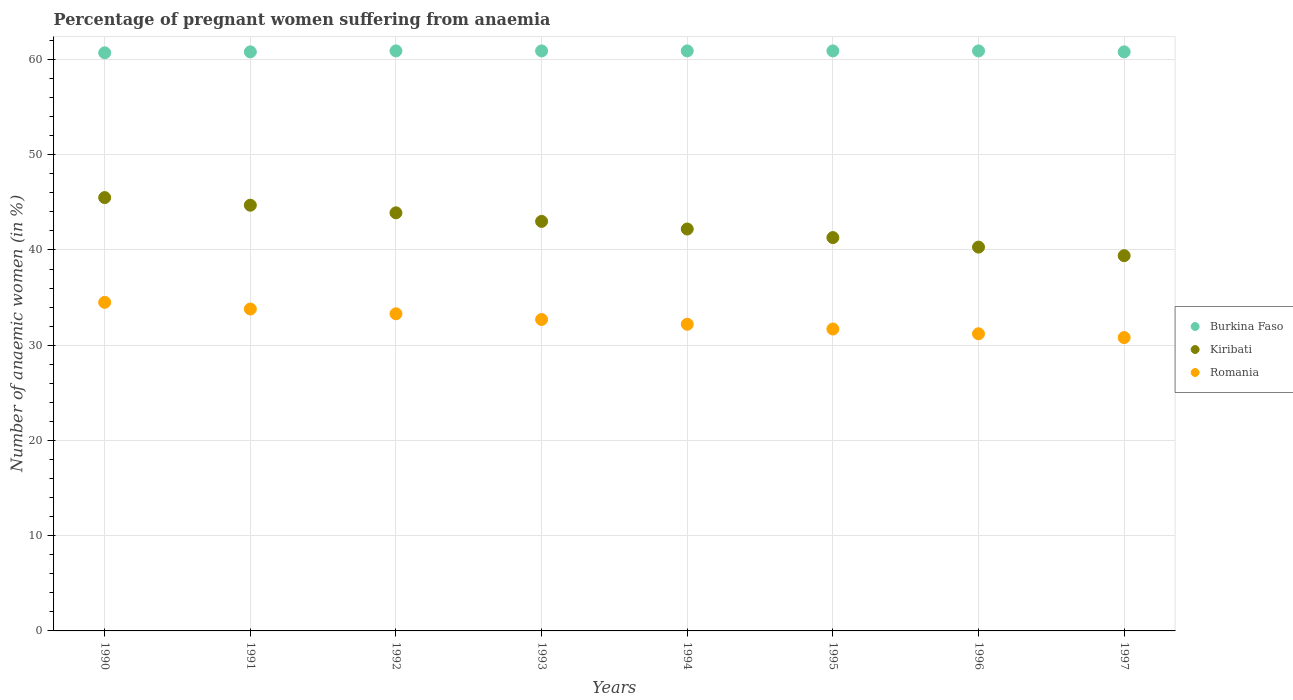How many different coloured dotlines are there?
Offer a terse response. 3. Is the number of dotlines equal to the number of legend labels?
Your answer should be compact. Yes. What is the number of anaemic women in Romania in 1990?
Offer a terse response. 34.5. Across all years, what is the maximum number of anaemic women in Burkina Faso?
Keep it short and to the point. 60.9. Across all years, what is the minimum number of anaemic women in Romania?
Give a very brief answer. 30.8. What is the total number of anaemic women in Kiribati in the graph?
Ensure brevity in your answer.  340.3. What is the difference between the number of anaemic women in Kiribati in 1993 and that in 1994?
Offer a very short reply. 0.8. What is the difference between the number of anaemic women in Burkina Faso in 1994 and the number of anaemic women in Romania in 1997?
Provide a short and direct response. 30.1. What is the average number of anaemic women in Romania per year?
Make the answer very short. 32.53. In the year 1995, what is the difference between the number of anaemic women in Kiribati and number of anaemic women in Burkina Faso?
Give a very brief answer. -19.6. What is the ratio of the number of anaemic women in Romania in 1990 to that in 1996?
Your response must be concise. 1.11. Is the difference between the number of anaemic women in Kiribati in 1991 and 1997 greater than the difference between the number of anaemic women in Burkina Faso in 1991 and 1997?
Provide a short and direct response. Yes. What is the difference between the highest and the second highest number of anaemic women in Burkina Faso?
Your answer should be very brief. 0. What is the difference between the highest and the lowest number of anaemic women in Kiribati?
Provide a succinct answer. 6.1. Is the sum of the number of anaemic women in Kiribati in 1996 and 1997 greater than the maximum number of anaemic women in Burkina Faso across all years?
Provide a succinct answer. Yes. Is it the case that in every year, the sum of the number of anaemic women in Kiribati and number of anaemic women in Burkina Faso  is greater than the number of anaemic women in Romania?
Keep it short and to the point. Yes. Does the number of anaemic women in Kiribati monotonically increase over the years?
Your answer should be compact. No. How many dotlines are there?
Your answer should be compact. 3. How many years are there in the graph?
Keep it short and to the point. 8. What is the difference between two consecutive major ticks on the Y-axis?
Provide a short and direct response. 10. Are the values on the major ticks of Y-axis written in scientific E-notation?
Keep it short and to the point. No. Does the graph contain any zero values?
Make the answer very short. No. How many legend labels are there?
Provide a short and direct response. 3. What is the title of the graph?
Offer a very short reply. Percentage of pregnant women suffering from anaemia. Does "Benin" appear as one of the legend labels in the graph?
Your answer should be compact. No. What is the label or title of the X-axis?
Provide a succinct answer. Years. What is the label or title of the Y-axis?
Your response must be concise. Number of anaemic women (in %). What is the Number of anaemic women (in %) of Burkina Faso in 1990?
Ensure brevity in your answer.  60.7. What is the Number of anaemic women (in %) of Kiribati in 1990?
Offer a very short reply. 45.5. What is the Number of anaemic women (in %) in Romania in 1990?
Your answer should be compact. 34.5. What is the Number of anaemic women (in %) in Burkina Faso in 1991?
Keep it short and to the point. 60.8. What is the Number of anaemic women (in %) of Kiribati in 1991?
Provide a succinct answer. 44.7. What is the Number of anaemic women (in %) in Romania in 1991?
Your answer should be compact. 33.8. What is the Number of anaemic women (in %) in Burkina Faso in 1992?
Keep it short and to the point. 60.9. What is the Number of anaemic women (in %) of Kiribati in 1992?
Make the answer very short. 43.9. What is the Number of anaemic women (in %) in Romania in 1992?
Offer a very short reply. 33.3. What is the Number of anaemic women (in %) in Burkina Faso in 1993?
Your answer should be very brief. 60.9. What is the Number of anaemic women (in %) of Kiribati in 1993?
Give a very brief answer. 43. What is the Number of anaemic women (in %) of Romania in 1993?
Your answer should be compact. 32.7. What is the Number of anaemic women (in %) of Burkina Faso in 1994?
Provide a short and direct response. 60.9. What is the Number of anaemic women (in %) in Kiribati in 1994?
Your answer should be very brief. 42.2. What is the Number of anaemic women (in %) in Romania in 1994?
Provide a succinct answer. 32.2. What is the Number of anaemic women (in %) of Burkina Faso in 1995?
Give a very brief answer. 60.9. What is the Number of anaemic women (in %) of Kiribati in 1995?
Provide a short and direct response. 41.3. What is the Number of anaemic women (in %) of Romania in 1995?
Keep it short and to the point. 31.7. What is the Number of anaemic women (in %) in Burkina Faso in 1996?
Give a very brief answer. 60.9. What is the Number of anaemic women (in %) of Kiribati in 1996?
Your response must be concise. 40.3. What is the Number of anaemic women (in %) of Romania in 1996?
Ensure brevity in your answer.  31.2. What is the Number of anaemic women (in %) in Burkina Faso in 1997?
Give a very brief answer. 60.8. What is the Number of anaemic women (in %) of Kiribati in 1997?
Offer a terse response. 39.4. What is the Number of anaemic women (in %) in Romania in 1997?
Keep it short and to the point. 30.8. Across all years, what is the maximum Number of anaemic women (in %) in Burkina Faso?
Your response must be concise. 60.9. Across all years, what is the maximum Number of anaemic women (in %) in Kiribati?
Provide a succinct answer. 45.5. Across all years, what is the maximum Number of anaemic women (in %) in Romania?
Offer a very short reply. 34.5. Across all years, what is the minimum Number of anaemic women (in %) of Burkina Faso?
Your response must be concise. 60.7. Across all years, what is the minimum Number of anaemic women (in %) in Kiribati?
Offer a terse response. 39.4. Across all years, what is the minimum Number of anaemic women (in %) in Romania?
Provide a succinct answer. 30.8. What is the total Number of anaemic women (in %) in Burkina Faso in the graph?
Provide a short and direct response. 486.8. What is the total Number of anaemic women (in %) in Kiribati in the graph?
Your response must be concise. 340.3. What is the total Number of anaemic women (in %) in Romania in the graph?
Ensure brevity in your answer.  260.2. What is the difference between the Number of anaemic women (in %) in Kiribati in 1990 and that in 1991?
Keep it short and to the point. 0.8. What is the difference between the Number of anaemic women (in %) of Romania in 1990 and that in 1991?
Your answer should be very brief. 0.7. What is the difference between the Number of anaemic women (in %) in Burkina Faso in 1990 and that in 1992?
Make the answer very short. -0.2. What is the difference between the Number of anaemic women (in %) of Romania in 1990 and that in 1992?
Keep it short and to the point. 1.2. What is the difference between the Number of anaemic women (in %) of Romania in 1990 and that in 1993?
Offer a very short reply. 1.8. What is the difference between the Number of anaemic women (in %) of Kiribati in 1990 and that in 1994?
Provide a short and direct response. 3.3. What is the difference between the Number of anaemic women (in %) of Romania in 1990 and that in 1994?
Make the answer very short. 2.3. What is the difference between the Number of anaemic women (in %) of Burkina Faso in 1990 and that in 1995?
Offer a terse response. -0.2. What is the difference between the Number of anaemic women (in %) of Romania in 1990 and that in 1996?
Provide a succinct answer. 3.3. What is the difference between the Number of anaemic women (in %) in Kiribati in 1990 and that in 1997?
Provide a succinct answer. 6.1. What is the difference between the Number of anaemic women (in %) in Romania in 1990 and that in 1997?
Make the answer very short. 3.7. What is the difference between the Number of anaemic women (in %) of Kiribati in 1991 and that in 1992?
Make the answer very short. 0.8. What is the difference between the Number of anaemic women (in %) of Burkina Faso in 1991 and that in 1993?
Offer a terse response. -0.1. What is the difference between the Number of anaemic women (in %) in Kiribati in 1991 and that in 1993?
Provide a short and direct response. 1.7. What is the difference between the Number of anaemic women (in %) of Romania in 1991 and that in 1993?
Ensure brevity in your answer.  1.1. What is the difference between the Number of anaemic women (in %) of Burkina Faso in 1991 and that in 1994?
Give a very brief answer. -0.1. What is the difference between the Number of anaemic women (in %) in Romania in 1991 and that in 1995?
Provide a short and direct response. 2.1. What is the difference between the Number of anaemic women (in %) in Burkina Faso in 1991 and that in 1996?
Keep it short and to the point. -0.1. What is the difference between the Number of anaemic women (in %) of Kiribati in 1991 and that in 1996?
Your response must be concise. 4.4. What is the difference between the Number of anaemic women (in %) of Romania in 1991 and that in 1997?
Offer a very short reply. 3. What is the difference between the Number of anaemic women (in %) of Romania in 1992 and that in 1993?
Your answer should be very brief. 0.6. What is the difference between the Number of anaemic women (in %) in Burkina Faso in 1992 and that in 1994?
Offer a terse response. 0. What is the difference between the Number of anaemic women (in %) of Romania in 1992 and that in 1994?
Ensure brevity in your answer.  1.1. What is the difference between the Number of anaemic women (in %) in Burkina Faso in 1992 and that in 1995?
Ensure brevity in your answer.  0. What is the difference between the Number of anaemic women (in %) of Romania in 1992 and that in 1995?
Ensure brevity in your answer.  1.6. What is the difference between the Number of anaemic women (in %) of Kiribati in 1992 and that in 1996?
Offer a very short reply. 3.6. What is the difference between the Number of anaemic women (in %) in Burkina Faso in 1992 and that in 1997?
Provide a succinct answer. 0.1. What is the difference between the Number of anaemic women (in %) of Burkina Faso in 1993 and that in 1995?
Give a very brief answer. 0. What is the difference between the Number of anaemic women (in %) of Burkina Faso in 1993 and that in 1996?
Ensure brevity in your answer.  0. What is the difference between the Number of anaemic women (in %) of Kiribati in 1993 and that in 1996?
Offer a terse response. 2.7. What is the difference between the Number of anaemic women (in %) of Romania in 1993 and that in 1996?
Offer a terse response. 1.5. What is the difference between the Number of anaemic women (in %) in Burkina Faso in 1993 and that in 1997?
Keep it short and to the point. 0.1. What is the difference between the Number of anaemic women (in %) of Romania in 1993 and that in 1997?
Offer a very short reply. 1.9. What is the difference between the Number of anaemic women (in %) in Kiribati in 1994 and that in 1995?
Provide a short and direct response. 0.9. What is the difference between the Number of anaemic women (in %) in Burkina Faso in 1994 and that in 1996?
Provide a short and direct response. 0. What is the difference between the Number of anaemic women (in %) in Romania in 1994 and that in 1996?
Offer a very short reply. 1. What is the difference between the Number of anaemic women (in %) in Burkina Faso in 1994 and that in 1997?
Provide a short and direct response. 0.1. What is the difference between the Number of anaemic women (in %) of Kiribati in 1995 and that in 1996?
Provide a short and direct response. 1. What is the difference between the Number of anaemic women (in %) in Romania in 1995 and that in 1996?
Offer a terse response. 0.5. What is the difference between the Number of anaemic women (in %) in Burkina Faso in 1995 and that in 1997?
Give a very brief answer. 0.1. What is the difference between the Number of anaemic women (in %) of Kiribati in 1995 and that in 1997?
Your answer should be compact. 1.9. What is the difference between the Number of anaemic women (in %) in Romania in 1995 and that in 1997?
Offer a very short reply. 0.9. What is the difference between the Number of anaemic women (in %) in Burkina Faso in 1996 and that in 1997?
Give a very brief answer. 0.1. What is the difference between the Number of anaemic women (in %) of Romania in 1996 and that in 1997?
Offer a very short reply. 0.4. What is the difference between the Number of anaemic women (in %) of Burkina Faso in 1990 and the Number of anaemic women (in %) of Romania in 1991?
Make the answer very short. 26.9. What is the difference between the Number of anaemic women (in %) in Kiribati in 1990 and the Number of anaemic women (in %) in Romania in 1991?
Offer a terse response. 11.7. What is the difference between the Number of anaemic women (in %) of Burkina Faso in 1990 and the Number of anaemic women (in %) of Kiribati in 1992?
Provide a short and direct response. 16.8. What is the difference between the Number of anaemic women (in %) of Burkina Faso in 1990 and the Number of anaemic women (in %) of Romania in 1992?
Your response must be concise. 27.4. What is the difference between the Number of anaemic women (in %) of Burkina Faso in 1990 and the Number of anaemic women (in %) of Romania in 1993?
Offer a terse response. 28. What is the difference between the Number of anaemic women (in %) in Burkina Faso in 1990 and the Number of anaemic women (in %) in Kiribati in 1995?
Provide a short and direct response. 19.4. What is the difference between the Number of anaemic women (in %) in Burkina Faso in 1990 and the Number of anaemic women (in %) in Kiribati in 1996?
Provide a short and direct response. 20.4. What is the difference between the Number of anaemic women (in %) in Burkina Faso in 1990 and the Number of anaemic women (in %) in Romania in 1996?
Give a very brief answer. 29.5. What is the difference between the Number of anaemic women (in %) in Burkina Faso in 1990 and the Number of anaemic women (in %) in Kiribati in 1997?
Your answer should be very brief. 21.3. What is the difference between the Number of anaemic women (in %) of Burkina Faso in 1990 and the Number of anaemic women (in %) of Romania in 1997?
Your response must be concise. 29.9. What is the difference between the Number of anaemic women (in %) of Kiribati in 1990 and the Number of anaemic women (in %) of Romania in 1997?
Your response must be concise. 14.7. What is the difference between the Number of anaemic women (in %) of Burkina Faso in 1991 and the Number of anaemic women (in %) of Kiribati in 1992?
Give a very brief answer. 16.9. What is the difference between the Number of anaemic women (in %) in Burkina Faso in 1991 and the Number of anaemic women (in %) in Romania in 1992?
Offer a terse response. 27.5. What is the difference between the Number of anaemic women (in %) in Burkina Faso in 1991 and the Number of anaemic women (in %) in Kiribati in 1993?
Your answer should be compact. 17.8. What is the difference between the Number of anaemic women (in %) of Burkina Faso in 1991 and the Number of anaemic women (in %) of Romania in 1993?
Give a very brief answer. 28.1. What is the difference between the Number of anaemic women (in %) of Kiribati in 1991 and the Number of anaemic women (in %) of Romania in 1993?
Provide a succinct answer. 12. What is the difference between the Number of anaemic women (in %) in Burkina Faso in 1991 and the Number of anaemic women (in %) in Kiribati in 1994?
Provide a short and direct response. 18.6. What is the difference between the Number of anaemic women (in %) in Burkina Faso in 1991 and the Number of anaemic women (in %) in Romania in 1994?
Your answer should be compact. 28.6. What is the difference between the Number of anaemic women (in %) in Kiribati in 1991 and the Number of anaemic women (in %) in Romania in 1994?
Make the answer very short. 12.5. What is the difference between the Number of anaemic women (in %) of Burkina Faso in 1991 and the Number of anaemic women (in %) of Romania in 1995?
Your answer should be very brief. 29.1. What is the difference between the Number of anaemic women (in %) in Kiribati in 1991 and the Number of anaemic women (in %) in Romania in 1995?
Give a very brief answer. 13. What is the difference between the Number of anaemic women (in %) in Burkina Faso in 1991 and the Number of anaemic women (in %) in Kiribati in 1996?
Offer a very short reply. 20.5. What is the difference between the Number of anaemic women (in %) of Burkina Faso in 1991 and the Number of anaemic women (in %) of Romania in 1996?
Provide a succinct answer. 29.6. What is the difference between the Number of anaemic women (in %) of Burkina Faso in 1991 and the Number of anaemic women (in %) of Kiribati in 1997?
Provide a short and direct response. 21.4. What is the difference between the Number of anaemic women (in %) of Burkina Faso in 1992 and the Number of anaemic women (in %) of Kiribati in 1993?
Give a very brief answer. 17.9. What is the difference between the Number of anaemic women (in %) in Burkina Faso in 1992 and the Number of anaemic women (in %) in Romania in 1993?
Give a very brief answer. 28.2. What is the difference between the Number of anaemic women (in %) in Kiribati in 1992 and the Number of anaemic women (in %) in Romania in 1993?
Your response must be concise. 11.2. What is the difference between the Number of anaemic women (in %) in Burkina Faso in 1992 and the Number of anaemic women (in %) in Kiribati in 1994?
Your answer should be very brief. 18.7. What is the difference between the Number of anaemic women (in %) of Burkina Faso in 1992 and the Number of anaemic women (in %) of Romania in 1994?
Provide a short and direct response. 28.7. What is the difference between the Number of anaemic women (in %) of Kiribati in 1992 and the Number of anaemic women (in %) of Romania in 1994?
Provide a short and direct response. 11.7. What is the difference between the Number of anaemic women (in %) of Burkina Faso in 1992 and the Number of anaemic women (in %) of Kiribati in 1995?
Your response must be concise. 19.6. What is the difference between the Number of anaemic women (in %) of Burkina Faso in 1992 and the Number of anaemic women (in %) of Romania in 1995?
Give a very brief answer. 29.2. What is the difference between the Number of anaemic women (in %) in Burkina Faso in 1992 and the Number of anaemic women (in %) in Kiribati in 1996?
Offer a terse response. 20.6. What is the difference between the Number of anaemic women (in %) in Burkina Faso in 1992 and the Number of anaemic women (in %) in Romania in 1996?
Keep it short and to the point. 29.7. What is the difference between the Number of anaemic women (in %) of Burkina Faso in 1992 and the Number of anaemic women (in %) of Kiribati in 1997?
Keep it short and to the point. 21.5. What is the difference between the Number of anaemic women (in %) in Burkina Faso in 1992 and the Number of anaemic women (in %) in Romania in 1997?
Your answer should be compact. 30.1. What is the difference between the Number of anaemic women (in %) of Kiribati in 1992 and the Number of anaemic women (in %) of Romania in 1997?
Offer a very short reply. 13.1. What is the difference between the Number of anaemic women (in %) of Burkina Faso in 1993 and the Number of anaemic women (in %) of Romania in 1994?
Ensure brevity in your answer.  28.7. What is the difference between the Number of anaemic women (in %) of Burkina Faso in 1993 and the Number of anaemic women (in %) of Kiribati in 1995?
Keep it short and to the point. 19.6. What is the difference between the Number of anaemic women (in %) in Burkina Faso in 1993 and the Number of anaemic women (in %) in Romania in 1995?
Provide a succinct answer. 29.2. What is the difference between the Number of anaemic women (in %) in Burkina Faso in 1993 and the Number of anaemic women (in %) in Kiribati in 1996?
Your answer should be compact. 20.6. What is the difference between the Number of anaemic women (in %) in Burkina Faso in 1993 and the Number of anaemic women (in %) in Romania in 1996?
Offer a terse response. 29.7. What is the difference between the Number of anaemic women (in %) of Burkina Faso in 1993 and the Number of anaemic women (in %) of Kiribati in 1997?
Provide a short and direct response. 21.5. What is the difference between the Number of anaemic women (in %) of Burkina Faso in 1993 and the Number of anaemic women (in %) of Romania in 1997?
Your answer should be very brief. 30.1. What is the difference between the Number of anaemic women (in %) in Kiribati in 1993 and the Number of anaemic women (in %) in Romania in 1997?
Make the answer very short. 12.2. What is the difference between the Number of anaemic women (in %) in Burkina Faso in 1994 and the Number of anaemic women (in %) in Kiribati in 1995?
Provide a succinct answer. 19.6. What is the difference between the Number of anaemic women (in %) in Burkina Faso in 1994 and the Number of anaemic women (in %) in Romania in 1995?
Provide a short and direct response. 29.2. What is the difference between the Number of anaemic women (in %) of Burkina Faso in 1994 and the Number of anaemic women (in %) of Kiribati in 1996?
Ensure brevity in your answer.  20.6. What is the difference between the Number of anaemic women (in %) in Burkina Faso in 1994 and the Number of anaemic women (in %) in Romania in 1996?
Offer a very short reply. 29.7. What is the difference between the Number of anaemic women (in %) of Kiribati in 1994 and the Number of anaemic women (in %) of Romania in 1996?
Make the answer very short. 11. What is the difference between the Number of anaemic women (in %) of Burkina Faso in 1994 and the Number of anaemic women (in %) of Kiribati in 1997?
Keep it short and to the point. 21.5. What is the difference between the Number of anaemic women (in %) of Burkina Faso in 1994 and the Number of anaemic women (in %) of Romania in 1997?
Provide a succinct answer. 30.1. What is the difference between the Number of anaemic women (in %) in Burkina Faso in 1995 and the Number of anaemic women (in %) in Kiribati in 1996?
Give a very brief answer. 20.6. What is the difference between the Number of anaemic women (in %) in Burkina Faso in 1995 and the Number of anaemic women (in %) in Romania in 1996?
Make the answer very short. 29.7. What is the difference between the Number of anaemic women (in %) in Burkina Faso in 1995 and the Number of anaemic women (in %) in Romania in 1997?
Your answer should be very brief. 30.1. What is the difference between the Number of anaemic women (in %) in Kiribati in 1995 and the Number of anaemic women (in %) in Romania in 1997?
Give a very brief answer. 10.5. What is the difference between the Number of anaemic women (in %) in Burkina Faso in 1996 and the Number of anaemic women (in %) in Kiribati in 1997?
Your answer should be compact. 21.5. What is the difference between the Number of anaemic women (in %) in Burkina Faso in 1996 and the Number of anaemic women (in %) in Romania in 1997?
Provide a short and direct response. 30.1. What is the average Number of anaemic women (in %) of Burkina Faso per year?
Keep it short and to the point. 60.85. What is the average Number of anaemic women (in %) in Kiribati per year?
Give a very brief answer. 42.54. What is the average Number of anaemic women (in %) in Romania per year?
Your response must be concise. 32.52. In the year 1990, what is the difference between the Number of anaemic women (in %) of Burkina Faso and Number of anaemic women (in %) of Romania?
Offer a very short reply. 26.2. In the year 1991, what is the difference between the Number of anaemic women (in %) in Burkina Faso and Number of anaemic women (in %) in Kiribati?
Your response must be concise. 16.1. In the year 1991, what is the difference between the Number of anaemic women (in %) in Burkina Faso and Number of anaemic women (in %) in Romania?
Provide a short and direct response. 27. In the year 1991, what is the difference between the Number of anaemic women (in %) in Kiribati and Number of anaemic women (in %) in Romania?
Your answer should be very brief. 10.9. In the year 1992, what is the difference between the Number of anaemic women (in %) of Burkina Faso and Number of anaemic women (in %) of Romania?
Offer a very short reply. 27.6. In the year 1992, what is the difference between the Number of anaemic women (in %) in Kiribati and Number of anaemic women (in %) in Romania?
Offer a terse response. 10.6. In the year 1993, what is the difference between the Number of anaemic women (in %) of Burkina Faso and Number of anaemic women (in %) of Romania?
Your answer should be very brief. 28.2. In the year 1993, what is the difference between the Number of anaemic women (in %) of Kiribati and Number of anaemic women (in %) of Romania?
Give a very brief answer. 10.3. In the year 1994, what is the difference between the Number of anaemic women (in %) of Burkina Faso and Number of anaemic women (in %) of Kiribati?
Provide a short and direct response. 18.7. In the year 1994, what is the difference between the Number of anaemic women (in %) in Burkina Faso and Number of anaemic women (in %) in Romania?
Ensure brevity in your answer.  28.7. In the year 1995, what is the difference between the Number of anaemic women (in %) of Burkina Faso and Number of anaemic women (in %) of Kiribati?
Give a very brief answer. 19.6. In the year 1995, what is the difference between the Number of anaemic women (in %) of Burkina Faso and Number of anaemic women (in %) of Romania?
Offer a terse response. 29.2. In the year 1995, what is the difference between the Number of anaemic women (in %) of Kiribati and Number of anaemic women (in %) of Romania?
Your response must be concise. 9.6. In the year 1996, what is the difference between the Number of anaemic women (in %) of Burkina Faso and Number of anaemic women (in %) of Kiribati?
Ensure brevity in your answer.  20.6. In the year 1996, what is the difference between the Number of anaemic women (in %) in Burkina Faso and Number of anaemic women (in %) in Romania?
Provide a short and direct response. 29.7. In the year 1997, what is the difference between the Number of anaemic women (in %) of Burkina Faso and Number of anaemic women (in %) of Kiribati?
Offer a terse response. 21.4. In the year 1997, what is the difference between the Number of anaemic women (in %) of Burkina Faso and Number of anaemic women (in %) of Romania?
Offer a terse response. 30. In the year 1997, what is the difference between the Number of anaemic women (in %) in Kiribati and Number of anaemic women (in %) in Romania?
Offer a terse response. 8.6. What is the ratio of the Number of anaemic women (in %) of Burkina Faso in 1990 to that in 1991?
Ensure brevity in your answer.  1. What is the ratio of the Number of anaemic women (in %) of Kiribati in 1990 to that in 1991?
Provide a succinct answer. 1.02. What is the ratio of the Number of anaemic women (in %) in Romania in 1990 to that in 1991?
Make the answer very short. 1.02. What is the ratio of the Number of anaemic women (in %) in Burkina Faso in 1990 to that in 1992?
Your answer should be compact. 1. What is the ratio of the Number of anaemic women (in %) in Kiribati in 1990 to that in 1992?
Provide a short and direct response. 1.04. What is the ratio of the Number of anaemic women (in %) of Romania in 1990 to that in 1992?
Give a very brief answer. 1.04. What is the ratio of the Number of anaemic women (in %) in Kiribati in 1990 to that in 1993?
Offer a terse response. 1.06. What is the ratio of the Number of anaemic women (in %) in Romania in 1990 to that in 1993?
Keep it short and to the point. 1.05. What is the ratio of the Number of anaemic women (in %) of Kiribati in 1990 to that in 1994?
Your answer should be compact. 1.08. What is the ratio of the Number of anaemic women (in %) of Romania in 1990 to that in 1994?
Make the answer very short. 1.07. What is the ratio of the Number of anaemic women (in %) in Kiribati in 1990 to that in 1995?
Your response must be concise. 1.1. What is the ratio of the Number of anaemic women (in %) in Romania in 1990 to that in 1995?
Give a very brief answer. 1.09. What is the ratio of the Number of anaemic women (in %) in Kiribati in 1990 to that in 1996?
Offer a very short reply. 1.13. What is the ratio of the Number of anaemic women (in %) in Romania in 1990 to that in 1996?
Offer a very short reply. 1.11. What is the ratio of the Number of anaemic women (in %) of Kiribati in 1990 to that in 1997?
Your response must be concise. 1.15. What is the ratio of the Number of anaemic women (in %) of Romania in 1990 to that in 1997?
Offer a very short reply. 1.12. What is the ratio of the Number of anaemic women (in %) in Kiribati in 1991 to that in 1992?
Ensure brevity in your answer.  1.02. What is the ratio of the Number of anaemic women (in %) in Romania in 1991 to that in 1992?
Provide a short and direct response. 1.01. What is the ratio of the Number of anaemic women (in %) of Burkina Faso in 1991 to that in 1993?
Your response must be concise. 1. What is the ratio of the Number of anaemic women (in %) in Kiribati in 1991 to that in 1993?
Ensure brevity in your answer.  1.04. What is the ratio of the Number of anaemic women (in %) of Romania in 1991 to that in 1993?
Ensure brevity in your answer.  1.03. What is the ratio of the Number of anaemic women (in %) of Burkina Faso in 1991 to that in 1994?
Make the answer very short. 1. What is the ratio of the Number of anaemic women (in %) of Kiribati in 1991 to that in 1994?
Keep it short and to the point. 1.06. What is the ratio of the Number of anaemic women (in %) in Romania in 1991 to that in 1994?
Ensure brevity in your answer.  1.05. What is the ratio of the Number of anaemic women (in %) of Burkina Faso in 1991 to that in 1995?
Offer a very short reply. 1. What is the ratio of the Number of anaemic women (in %) of Kiribati in 1991 to that in 1995?
Provide a short and direct response. 1.08. What is the ratio of the Number of anaemic women (in %) of Romania in 1991 to that in 1995?
Ensure brevity in your answer.  1.07. What is the ratio of the Number of anaemic women (in %) in Burkina Faso in 1991 to that in 1996?
Your answer should be compact. 1. What is the ratio of the Number of anaemic women (in %) in Kiribati in 1991 to that in 1996?
Your answer should be very brief. 1.11. What is the ratio of the Number of anaemic women (in %) in Romania in 1991 to that in 1996?
Provide a short and direct response. 1.08. What is the ratio of the Number of anaemic women (in %) in Kiribati in 1991 to that in 1997?
Your response must be concise. 1.13. What is the ratio of the Number of anaemic women (in %) in Romania in 1991 to that in 1997?
Your answer should be very brief. 1.1. What is the ratio of the Number of anaemic women (in %) of Kiribati in 1992 to that in 1993?
Give a very brief answer. 1.02. What is the ratio of the Number of anaemic women (in %) of Romania in 1992 to that in 1993?
Offer a very short reply. 1.02. What is the ratio of the Number of anaemic women (in %) in Burkina Faso in 1992 to that in 1994?
Keep it short and to the point. 1. What is the ratio of the Number of anaemic women (in %) of Kiribati in 1992 to that in 1994?
Your response must be concise. 1.04. What is the ratio of the Number of anaemic women (in %) in Romania in 1992 to that in 1994?
Your answer should be very brief. 1.03. What is the ratio of the Number of anaemic women (in %) of Burkina Faso in 1992 to that in 1995?
Give a very brief answer. 1. What is the ratio of the Number of anaemic women (in %) in Kiribati in 1992 to that in 1995?
Provide a succinct answer. 1.06. What is the ratio of the Number of anaemic women (in %) in Romania in 1992 to that in 1995?
Offer a very short reply. 1.05. What is the ratio of the Number of anaemic women (in %) of Kiribati in 1992 to that in 1996?
Ensure brevity in your answer.  1.09. What is the ratio of the Number of anaemic women (in %) in Romania in 1992 to that in 1996?
Provide a short and direct response. 1.07. What is the ratio of the Number of anaemic women (in %) of Kiribati in 1992 to that in 1997?
Your response must be concise. 1.11. What is the ratio of the Number of anaemic women (in %) of Romania in 1992 to that in 1997?
Keep it short and to the point. 1.08. What is the ratio of the Number of anaemic women (in %) of Burkina Faso in 1993 to that in 1994?
Offer a very short reply. 1. What is the ratio of the Number of anaemic women (in %) of Romania in 1993 to that in 1994?
Offer a terse response. 1.02. What is the ratio of the Number of anaemic women (in %) of Kiribati in 1993 to that in 1995?
Provide a short and direct response. 1.04. What is the ratio of the Number of anaemic women (in %) of Romania in 1993 to that in 1995?
Your response must be concise. 1.03. What is the ratio of the Number of anaemic women (in %) of Burkina Faso in 1993 to that in 1996?
Your answer should be compact. 1. What is the ratio of the Number of anaemic women (in %) of Kiribati in 1993 to that in 1996?
Ensure brevity in your answer.  1.07. What is the ratio of the Number of anaemic women (in %) in Romania in 1993 to that in 1996?
Keep it short and to the point. 1.05. What is the ratio of the Number of anaemic women (in %) in Burkina Faso in 1993 to that in 1997?
Give a very brief answer. 1. What is the ratio of the Number of anaemic women (in %) in Kiribati in 1993 to that in 1997?
Offer a terse response. 1.09. What is the ratio of the Number of anaemic women (in %) of Romania in 1993 to that in 1997?
Give a very brief answer. 1.06. What is the ratio of the Number of anaemic women (in %) in Burkina Faso in 1994 to that in 1995?
Offer a very short reply. 1. What is the ratio of the Number of anaemic women (in %) in Kiribati in 1994 to that in 1995?
Provide a short and direct response. 1.02. What is the ratio of the Number of anaemic women (in %) of Romania in 1994 to that in 1995?
Provide a short and direct response. 1.02. What is the ratio of the Number of anaemic women (in %) in Kiribati in 1994 to that in 1996?
Offer a very short reply. 1.05. What is the ratio of the Number of anaemic women (in %) of Romania in 1994 to that in 1996?
Give a very brief answer. 1.03. What is the ratio of the Number of anaemic women (in %) of Burkina Faso in 1994 to that in 1997?
Provide a short and direct response. 1. What is the ratio of the Number of anaemic women (in %) in Kiribati in 1994 to that in 1997?
Keep it short and to the point. 1.07. What is the ratio of the Number of anaemic women (in %) of Romania in 1994 to that in 1997?
Offer a terse response. 1.05. What is the ratio of the Number of anaemic women (in %) of Burkina Faso in 1995 to that in 1996?
Provide a short and direct response. 1. What is the ratio of the Number of anaemic women (in %) in Kiribati in 1995 to that in 1996?
Provide a succinct answer. 1.02. What is the ratio of the Number of anaemic women (in %) in Romania in 1995 to that in 1996?
Your answer should be compact. 1.02. What is the ratio of the Number of anaemic women (in %) of Kiribati in 1995 to that in 1997?
Provide a succinct answer. 1.05. What is the ratio of the Number of anaemic women (in %) in Romania in 1995 to that in 1997?
Offer a very short reply. 1.03. What is the ratio of the Number of anaemic women (in %) in Burkina Faso in 1996 to that in 1997?
Your answer should be compact. 1. What is the ratio of the Number of anaemic women (in %) in Kiribati in 1996 to that in 1997?
Your response must be concise. 1.02. What is the difference between the highest and the second highest Number of anaemic women (in %) in Burkina Faso?
Ensure brevity in your answer.  0. What is the difference between the highest and the second highest Number of anaemic women (in %) of Kiribati?
Ensure brevity in your answer.  0.8. What is the difference between the highest and the lowest Number of anaemic women (in %) in Kiribati?
Offer a very short reply. 6.1. 